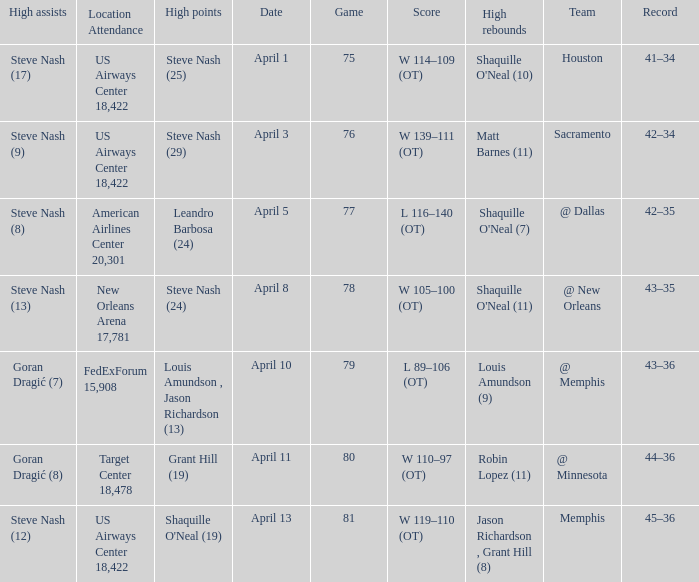What was the team's score on April 1? W 114–109 (OT). 